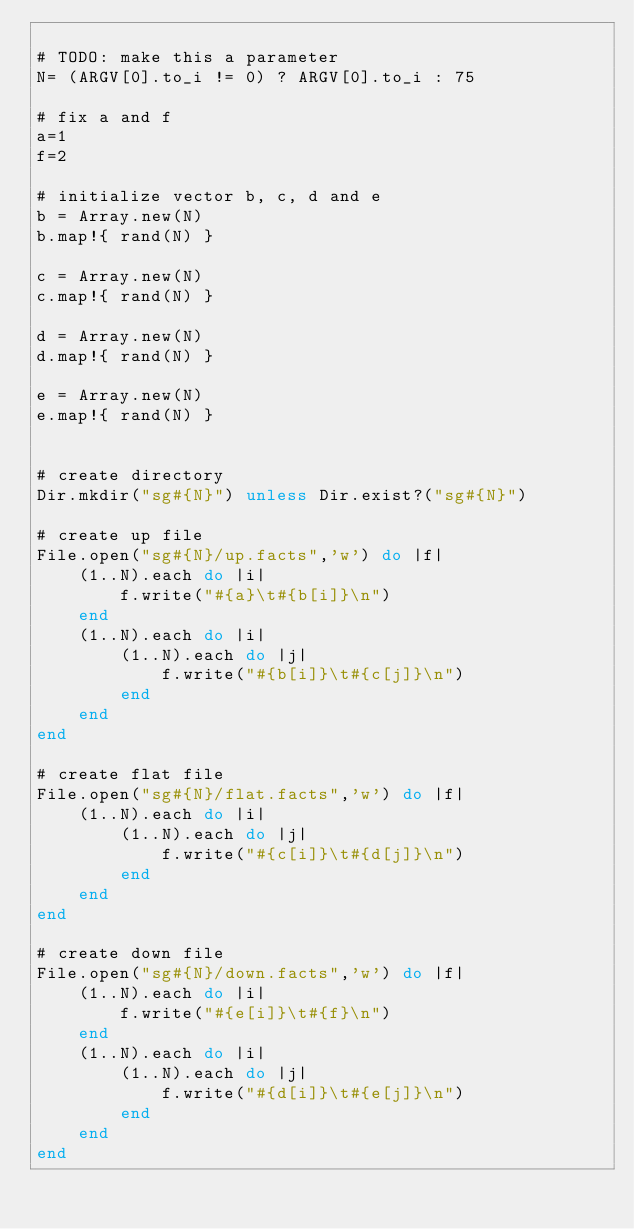Convert code to text. <code><loc_0><loc_0><loc_500><loc_500><_Ruby_>
# TODO: make this a parameter
N= (ARGV[0].to_i != 0) ? ARGV[0].to_i : 75

# fix a and f
a=1
f=2

# initialize vector b, c, d and e
b = Array.new(N)
b.map!{ rand(N) }

c = Array.new(N)
c.map!{ rand(N) }

d = Array.new(N)
d.map!{ rand(N) }

e = Array.new(N)
e.map!{ rand(N) }


# create directory
Dir.mkdir("sg#{N}") unless Dir.exist?("sg#{N}")

# create up file
File.open("sg#{N}/up.facts",'w') do |f|
    (1..N).each do |i| 
        f.write("#{a}\t#{b[i]}\n")
    end
    (1..N).each do |i| 
        (1..N).each do |j|
            f.write("#{b[i]}\t#{c[j]}\n")
        end
    end
end

# create flat file
File.open("sg#{N}/flat.facts",'w') do |f|
    (1..N).each do |i| 
        (1..N).each do |j|
            f.write("#{c[i]}\t#{d[j]}\n")
        end
    end
end

# create down file
File.open("sg#{N}/down.facts",'w') do |f|
    (1..N).each do |i| 
        f.write("#{e[i]}\t#{f}\n")
    end
    (1..N).each do |i| 
        (1..N).each do |j|
            f.write("#{d[i]}\t#{e[j]}\n")
        end
    end
end
</code> 